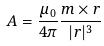<formula> <loc_0><loc_0><loc_500><loc_500>A = \frac { \mu _ { 0 } } { 4 \pi } \frac { m \times r } { | r | ^ { 3 } }</formula> 